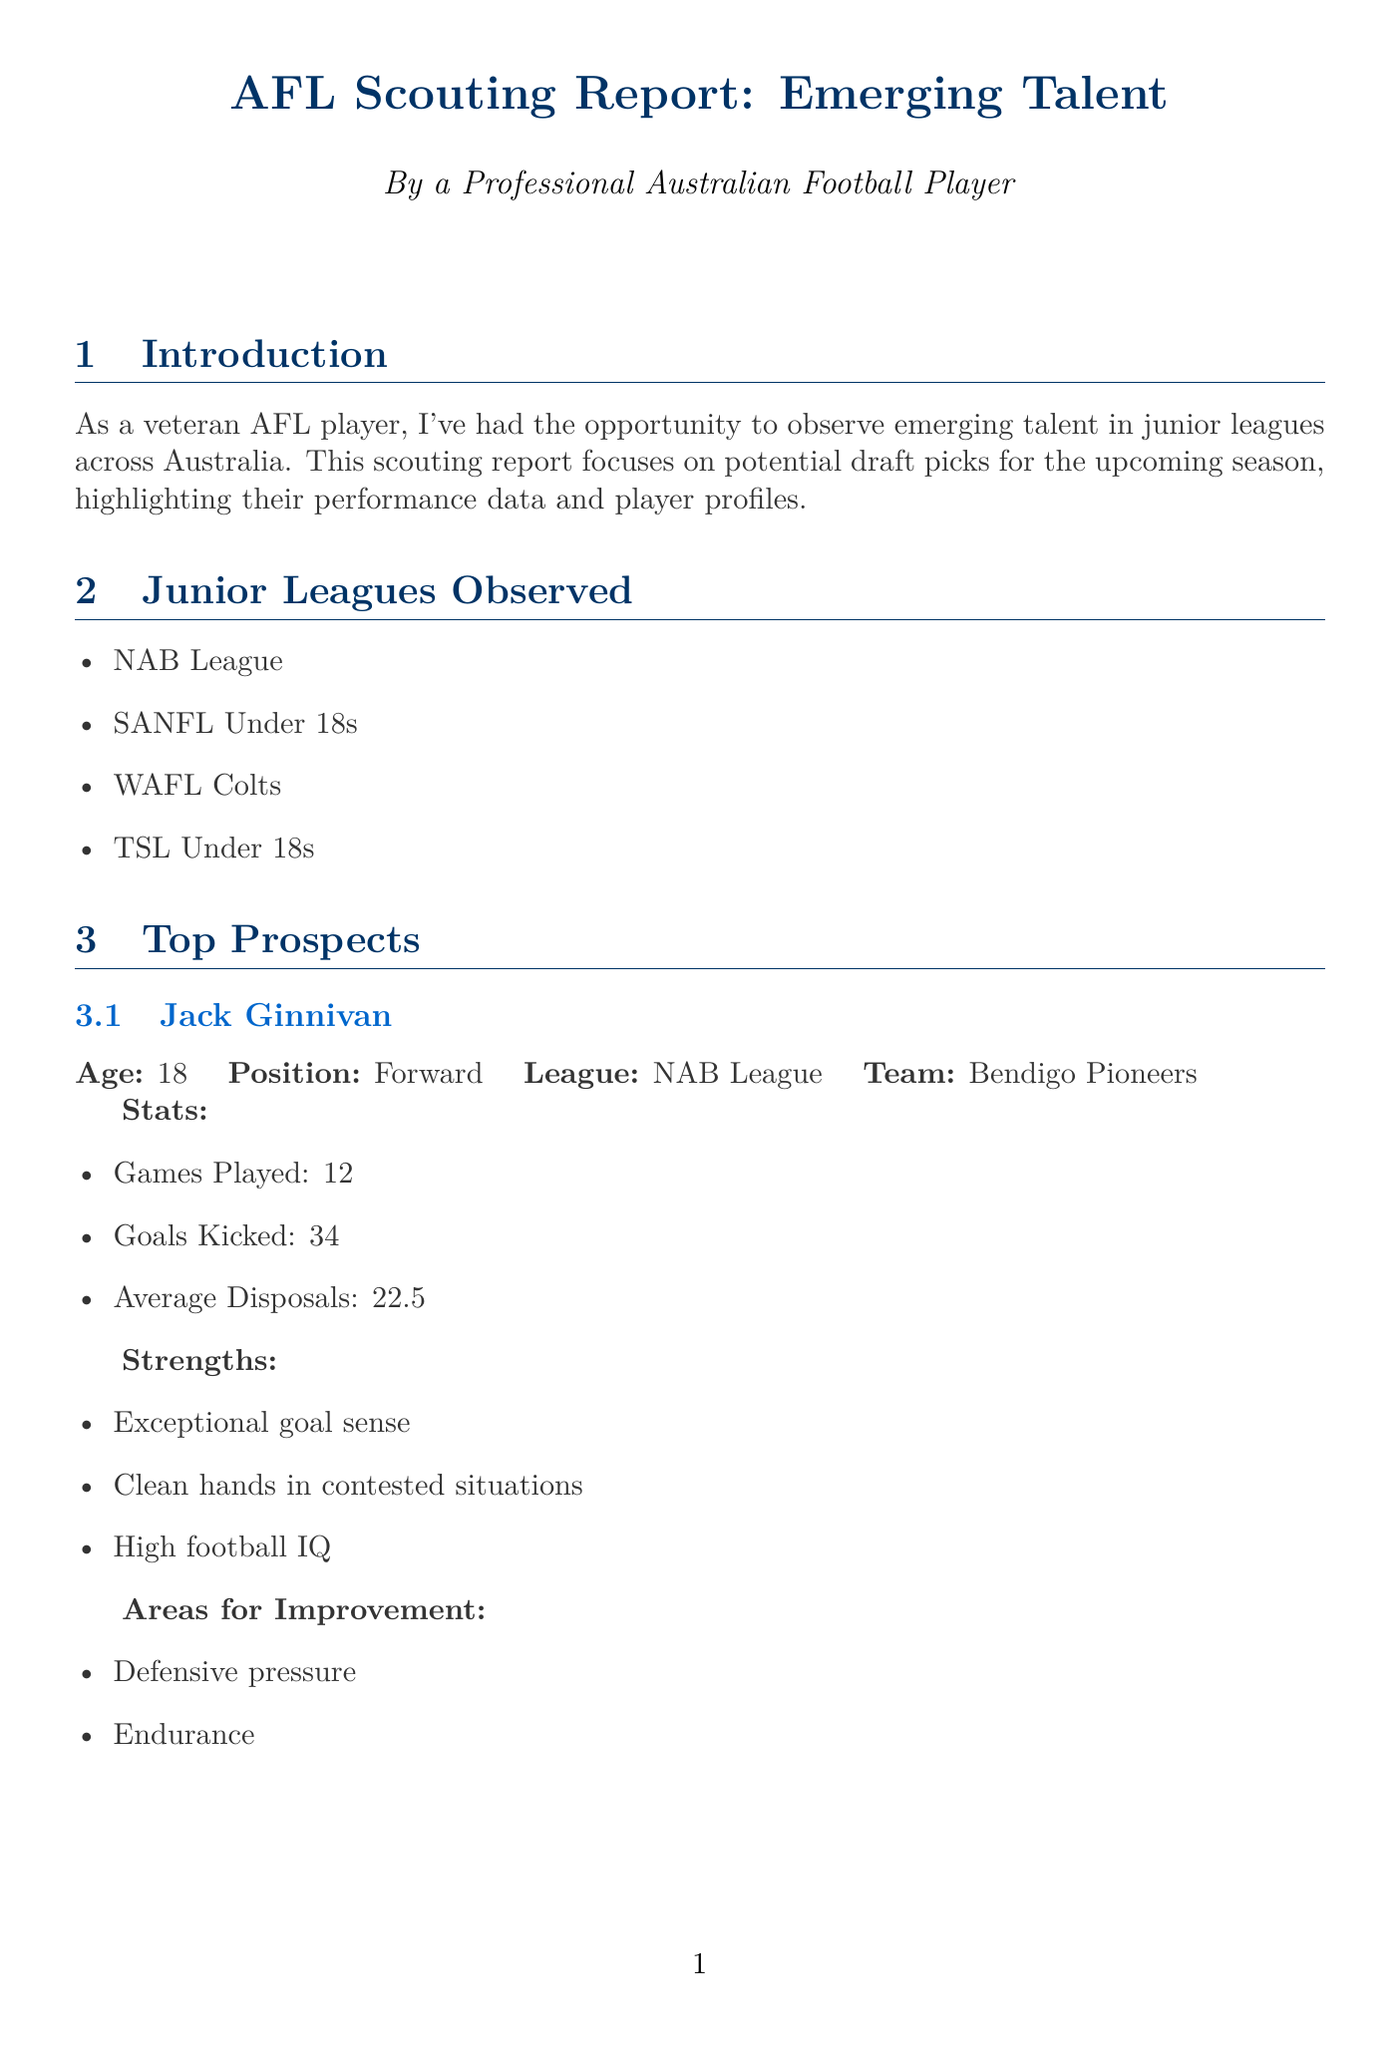What is the main focus of the scouting report? The scouting report focuses on potential draft picks for the upcoming season, highlighting their performance data and player profiles.
Answer: Potential draft picks How many games did Jack Ginnivan play? The report states that Jack Ginnivan played 12 games.
Answer: 12 What is Elijah Hollands' average disposals per game? The document shows that Elijah Hollands has an average of 26.8 disposals per game.
Answer: 26.8 Who is the top pick predicted in the draft? The document identifies Jack Ginnivan as the top pick.
Answer: Jack Ginnivan What area does Riley Thilthorpe need to improve in? The report mentions that Riley Thilthorpe needs to improve in consistency in ruck contests.
Answer: Consistency in ruck contests What scouting methodology was used? The report lists game footage analysis as one of the methodologies used for scouting.
Answer: Game footage analysis Which player is noted as a riser to watch? The report indicates that Elijah Hollands is a riser to watch.
Answer: Elijah Hollands What metric measures disposal efficiency? Disposal efficiency is one of the key metrics mentioned in the scouting report.
Answer: Disposal efficiency 